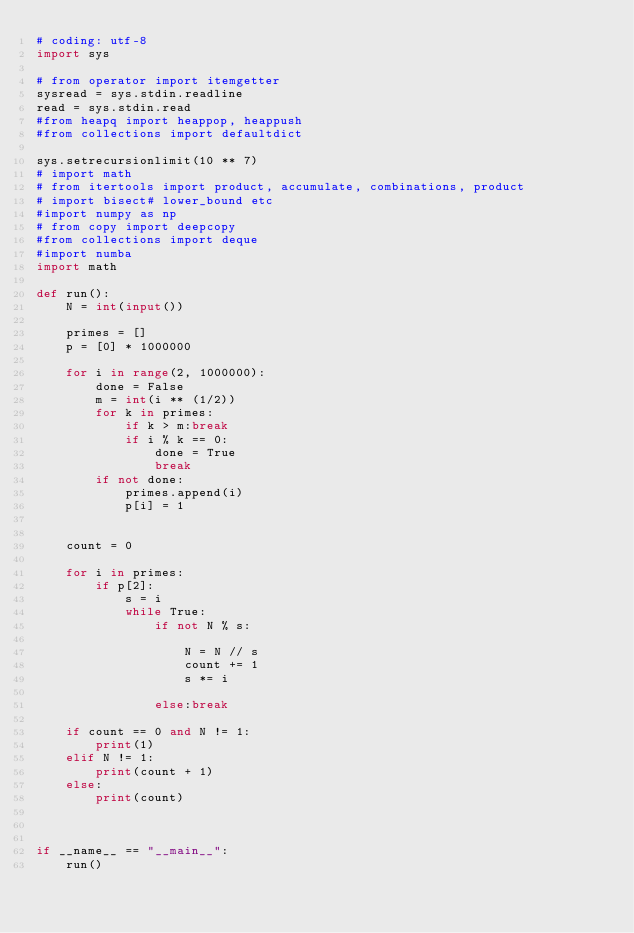<code> <loc_0><loc_0><loc_500><loc_500><_Python_># coding: utf-8
import sys

# from operator import itemgetter
sysread = sys.stdin.readline
read = sys.stdin.read
#from heapq import heappop, heappush
#from collections import defaultdict

sys.setrecursionlimit(10 ** 7)
# import math
# from itertools import product, accumulate, combinations, product
# import bisect# lower_bound etc
#import numpy as np
# from copy import deepcopy
#from collections import deque
#import numba
import math

def run():
    N = int(input())

    primes = []
    p = [0] * 1000000

    for i in range(2, 1000000):
        done = False
        m = int(i ** (1/2))
        for k in primes:
            if k > m:break
            if i % k == 0:
                done = True
                break
        if not done:
            primes.append(i)
            p[i] = 1


    count = 0

    for i in primes:
        if p[2]:
            s = i
            while True:
                if not N % s:

                    N = N // s
                    count += 1
                    s *= i

                else:break

    if count == 0 and N != 1:
        print(1)
    elif N != 1:
        print(count + 1)
    else:
        print(count)



if __name__ == "__main__":
    run()</code> 